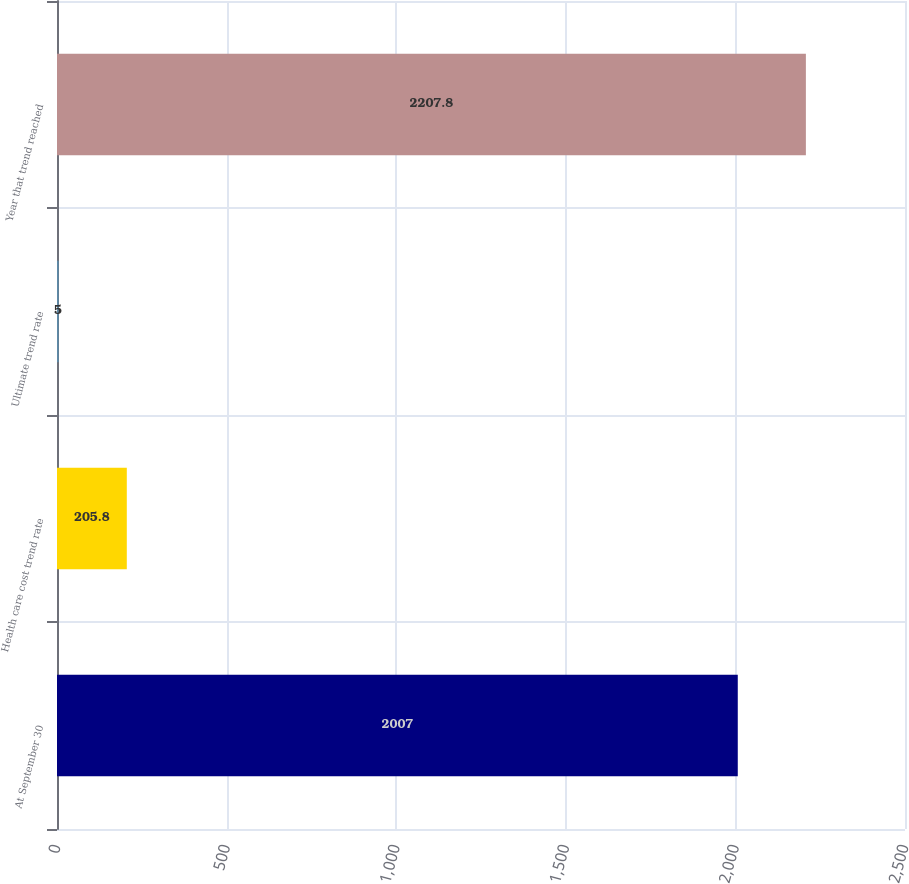Convert chart to OTSL. <chart><loc_0><loc_0><loc_500><loc_500><bar_chart><fcel>At September 30<fcel>Health care cost trend rate<fcel>Ultimate trend rate<fcel>Year that trend reached<nl><fcel>2007<fcel>205.8<fcel>5<fcel>2207.8<nl></chart> 